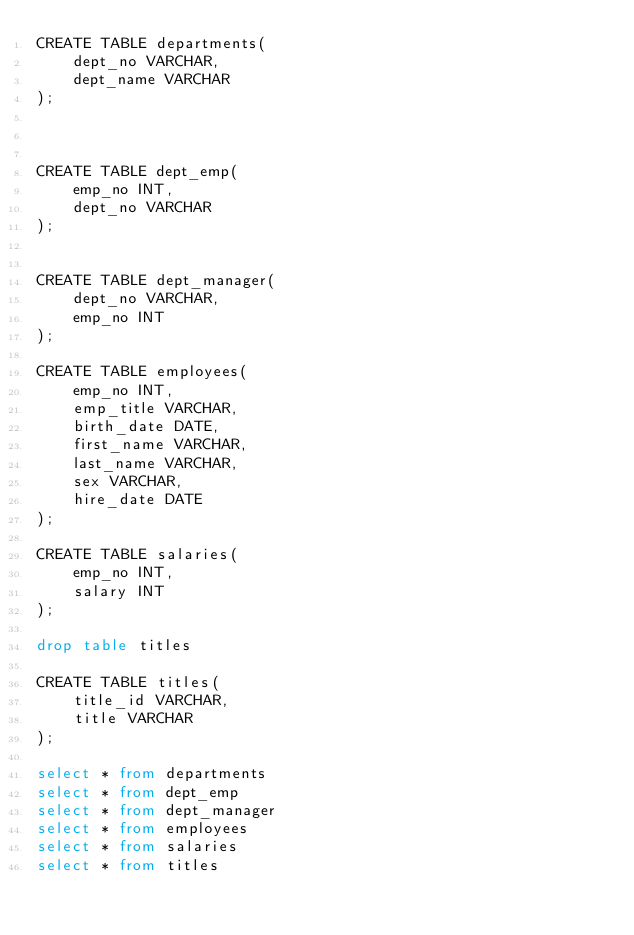Convert code to text. <code><loc_0><loc_0><loc_500><loc_500><_SQL_>CREATE TABLE departments(
    dept_no VARCHAR,
    dept_name VARCHAR
);



CREATE TABLE dept_emp(
    emp_no INT,
    dept_no VARCHAR
);


CREATE TABLE dept_manager(
    dept_no VARCHAR,
    emp_no INT
);

CREATE TABLE employees(
    emp_no INT,
    emp_title VARCHAR,
    birth_date DATE,
    first_name VARCHAR,
    last_name VARCHAR,
    sex VARCHAR,
    hire_date DATE
);

CREATE TABLE salaries(
    emp_no INT,
    salary INT
);

drop table titles

CREATE TABLE titles(
    title_id VARCHAR,
    title VARCHAR
);

select * from departments
select * from dept_emp
select * from dept_manager
select * from employees
select * from salaries
select * from titles

</code> 